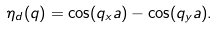<formula> <loc_0><loc_0><loc_500><loc_500>\eta _ { d } ( { q } ) = \cos ( q _ { x } a ) - \cos ( q _ { y } a ) .</formula> 